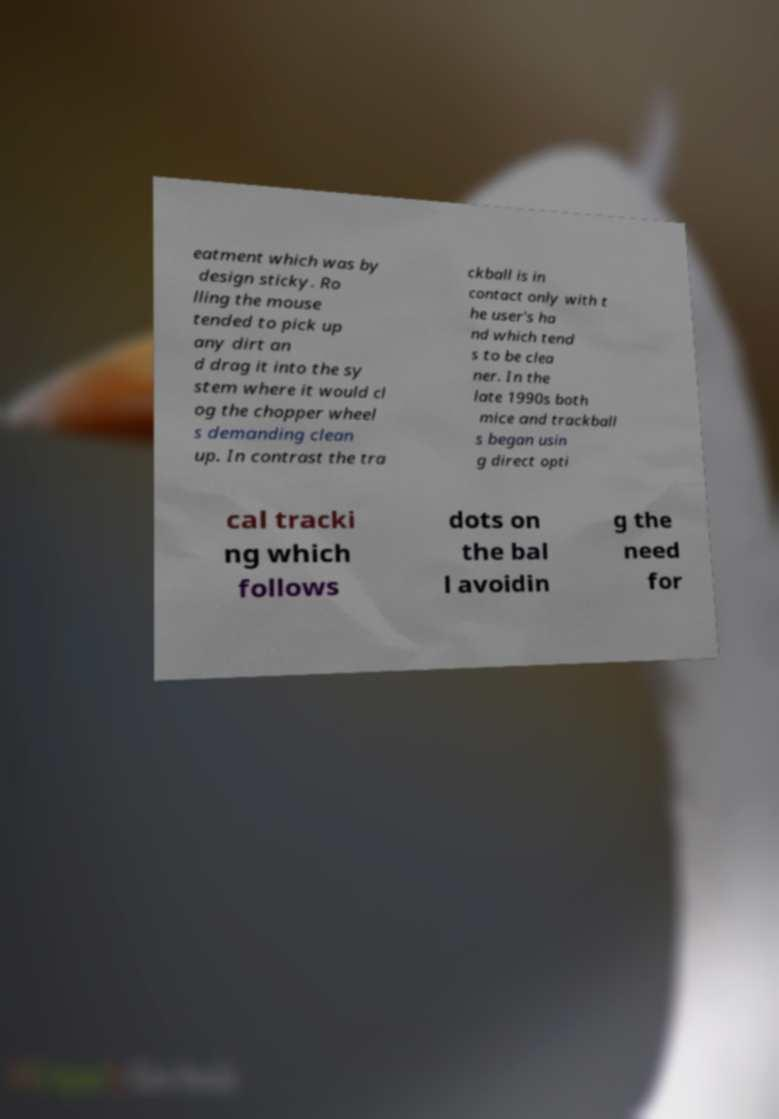Can you read and provide the text displayed in the image?This photo seems to have some interesting text. Can you extract and type it out for me? eatment which was by design sticky. Ro lling the mouse tended to pick up any dirt an d drag it into the sy stem where it would cl og the chopper wheel s demanding clean up. In contrast the tra ckball is in contact only with t he user's ha nd which tend s to be clea ner. In the late 1990s both mice and trackball s began usin g direct opti cal tracki ng which follows dots on the bal l avoidin g the need for 